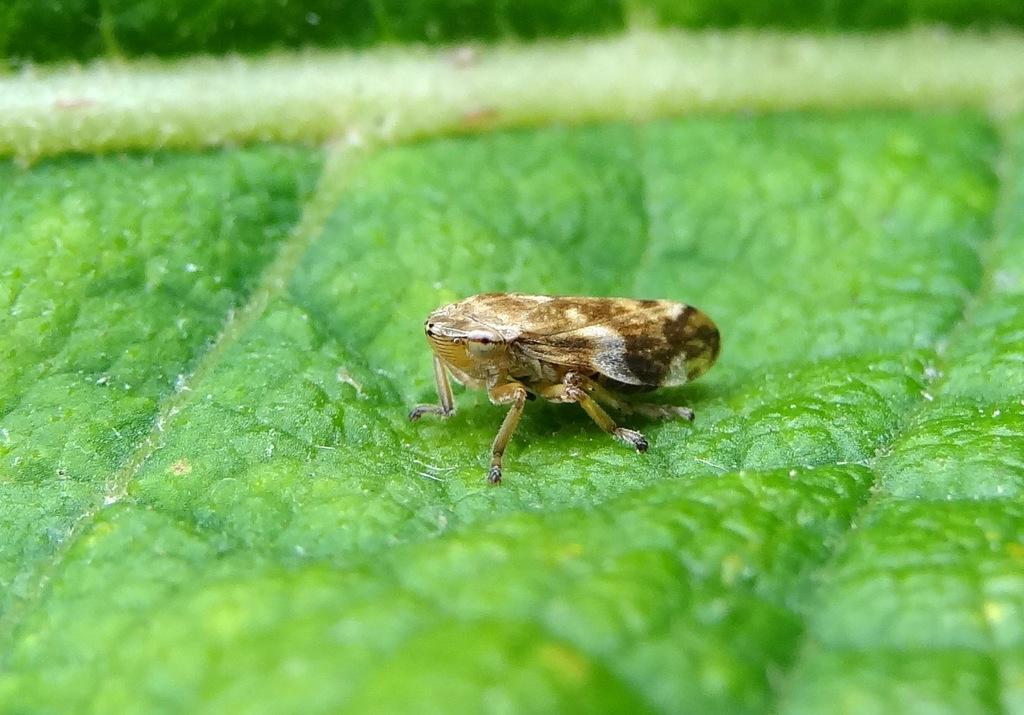Can you describe this image briefly? In the center of a picture we can see an insect on a green colored object. 